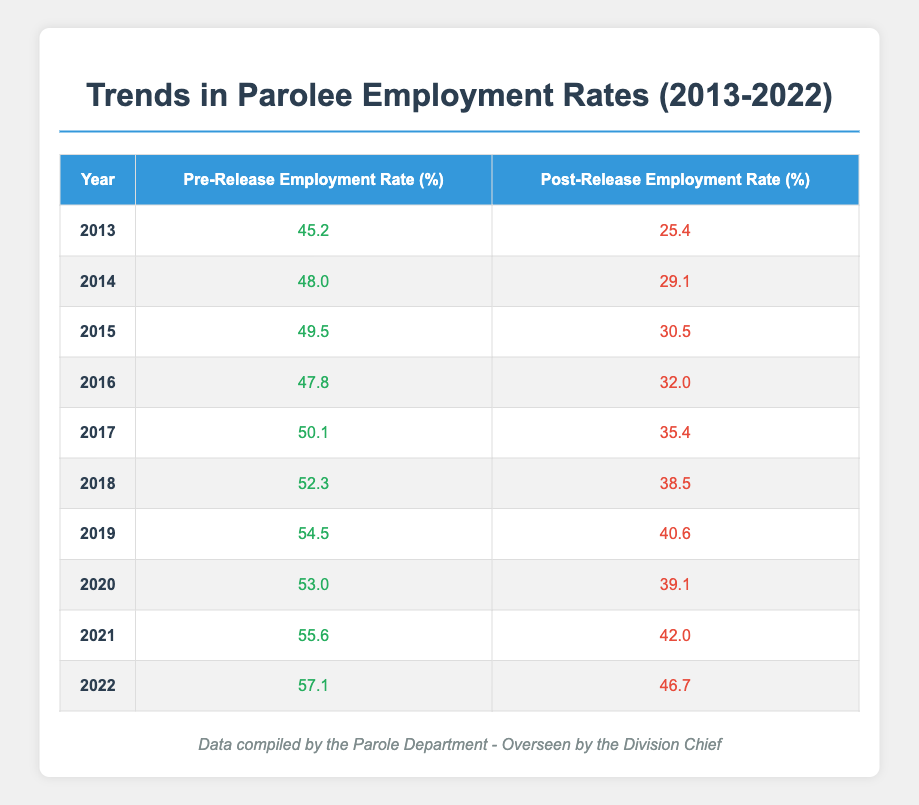What was the Pre-Release Employment Rate in 2015? The table shows the Pre-Release Employment Rate for each year. In 2015, the rate listed is 49.5%.
Answer: 49.5 What was the Post-Release Employment Rate in 2018? According to the table, the Post-Release Employment Rate for 2018 is provided as 38.5%.
Answer: 38.5 Which year had the highest Pre-Release Employment Rate? By examining the Pre-Release Employment Rate column, the highest rate is 57.1% recorded in 2022.
Answer: 2022 What was the change in Post-Release Employment Rate from 2013 to 2022? To find the change, subtract the Post-Release Employment Rate of 2013 (25.4%) from that of 2022 (46.7%). The calculation is 46.7 - 25.4 = 21.3%.
Answer: 21.3% Is the Post-Release Employment Rate higher than the Pre-Release Employment Rate for any year in this table? A quick review shows that all Post-Release Employment Rates are lower than their respective Pre-Release Rates in each year listed, so the answer is no.
Answer: No What is the average Pre-Release Employment Rate over the decade? To calculate the average, sum all the rates: (45.2 + 48.0 + 49.5 + 47.8 + 50.1 + 52.3 + 54.5 + 53.0 + 55.6 + 57.1) =  508.1, and divide by the number of years (10): 508.1 / 10 = 50.81%.
Answer: 50.81 In which year was the percentage difference between Pre-Release and Post-Release Employment Rates the largest? To find the largest difference, subtract the Post-Release Employment Rate from the Pre-Release Employment Rate for each year. The largest difference occurs in 2013: 45.2 - 25.4 = 19.8%. Checking the other years will show this is the largest.
Answer: 2013 How many years had a Post-Release Employment Rate below 30%? The table lists the years 2013, 2014, and 2015 with Post-Release Employment Rates below 30%: 25.4% in 2013, 29.1% in 2014, and 30.5% in 2015. Therefore, there are 2 years in total that qualify.
Answer: 2 What was the average Post-Release Employment Rate for the last five years (2018 to 2022)? To calculate, sum the Post-Release Employment Rates for these years: (38.5 + 40.6 + 39.1 + 42.0 + 46.7) = 206.9 and divide by 5: 206.9 / 5 = 41.38%.
Answer: 41.38 